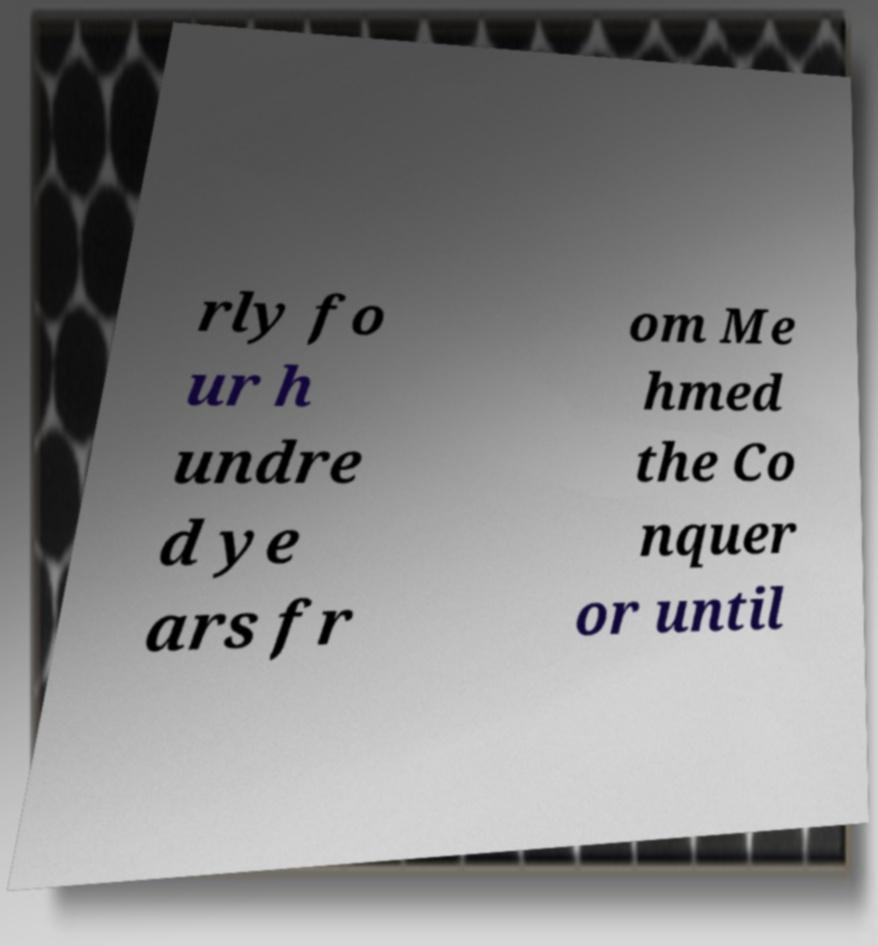Could you extract and type out the text from this image? rly fo ur h undre d ye ars fr om Me hmed the Co nquer or until 